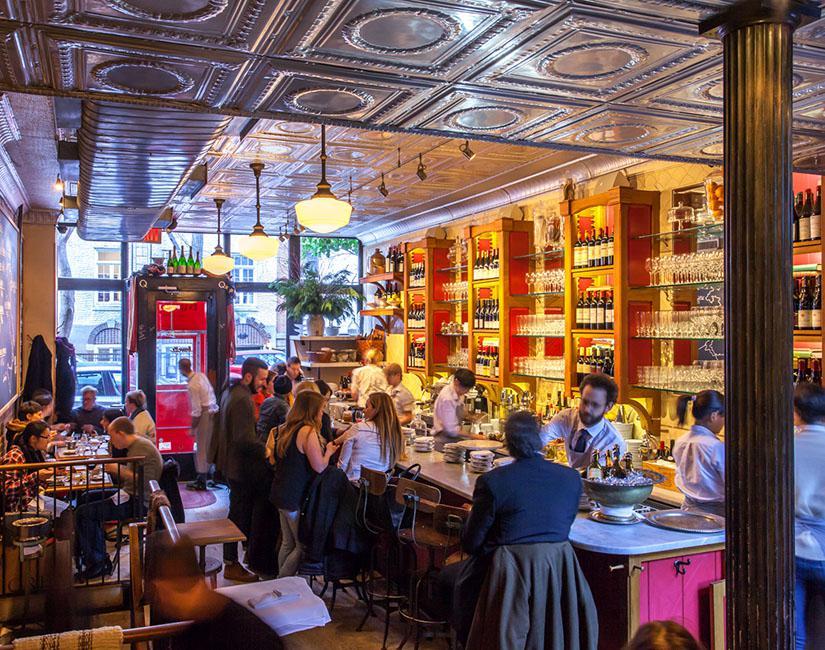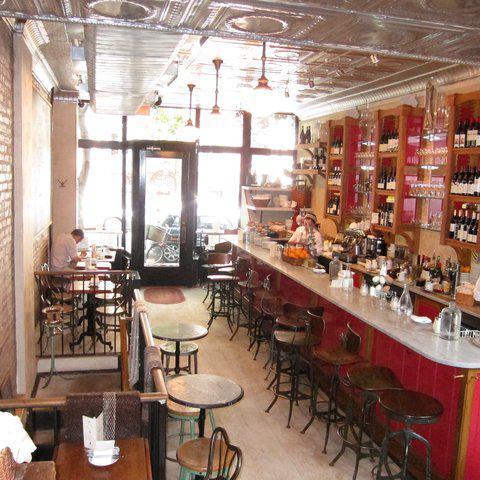The first image is the image on the left, the second image is the image on the right. For the images displayed, is the sentence "There are at least  three bartender with white shirt and ties serving customers from behind the bar." factually correct? Answer yes or no. Yes. 